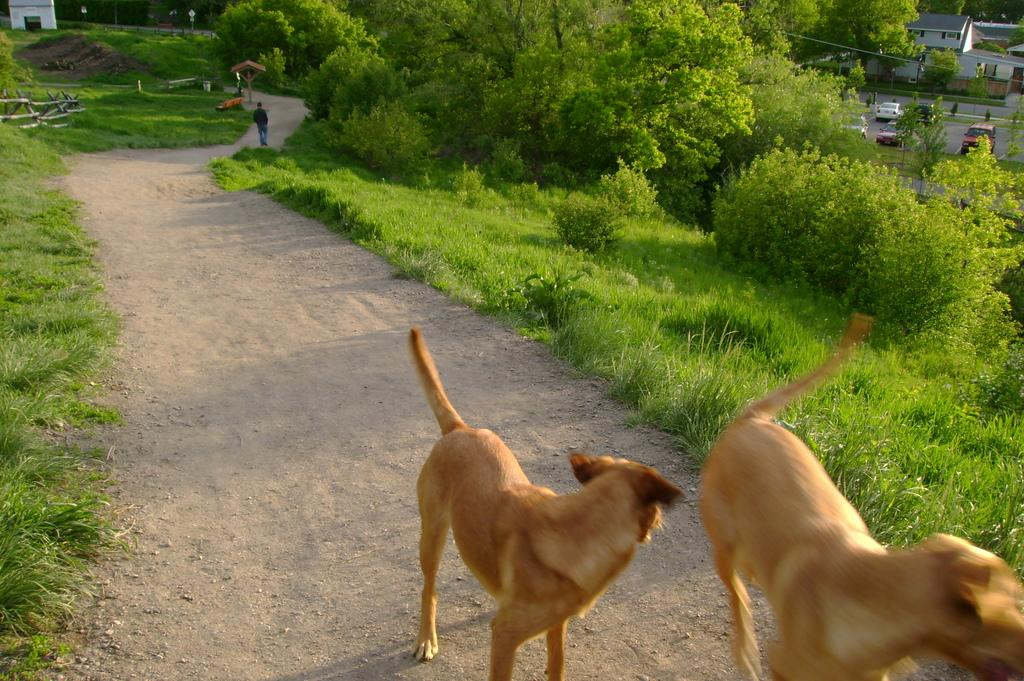How many dogs are in the image? There are two dogs on the ground in the image. What type of surface are the dogs on? The dogs are on grass in the image. What other natural elements can be seen in the image? Trees are visible in the image. What type of man-made structures are present in the image? There are buildings in the image. What type of transportation is visible in the image? Vehicles are on the road in the image. Can you describe the person in the background of the image? There is a person walking in the background of the image. What type of writing can be seen on the wrist of the person walking in the image? There is no writing visible on the wrist of the person walking in the image. 